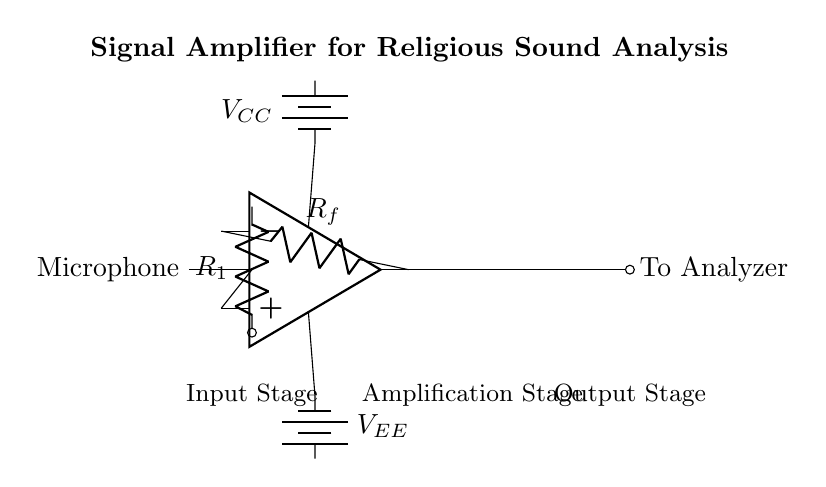What is the type of amplifier used in this circuit? The circuit uses an operational amplifier, which is specifically designed to amplify voltage signals. The symbol for the operational amplifier is shown in the center of the circuit.
Answer: Operational amplifier What does R1 represent in the circuit? R1 is the input resistor that is connected to the microphone, limiting the current entering the amplifier and helping to set the input impedance.
Answer: Input resistor What is the purpose of the feedback resistor Rf? Rf is the feedback resistor that controls the gain of the operational amplifier by determining how much of the output is fed back into the inverting input. This is essential for achieving the desired amplification characteristics.
Answer: Gain control What are the voltage supplies labeled in the circuit? The circuit has two voltage supplies labeled V_CC and V_EE, which provide the necessary power for the operational amplifier to function. V_CC is the positive supply, while V_EE is the negative supply.
Answer: V_CC and V_EE How is the output of the amplifier represented in the circuit? The output of the amplifier is represented by the node connected to the output terminal of the operational amplifier, which is labeled "To Analyzer." This indicates where the amplified signal will go for analysis of religious sound patterns.
Answer: To Analyzer What does the term "Amplification Stage" refer to in this circuit? The Amplification Stage refers to the section of the circuit where the operational amplifier is located. This is where the actual amplification of the input signal occurs, as the op-amp increases the voltage for analysis purposes.
Answer: Amplification Stage 